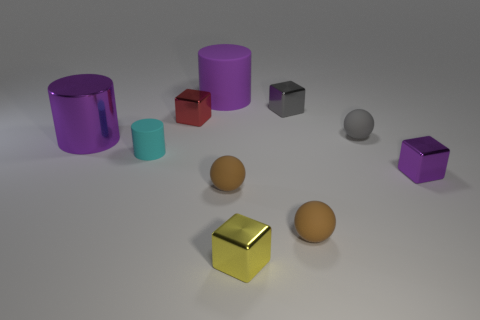Subtract all small gray balls. How many balls are left? 2 Subtract all balls. How many objects are left? 7 Subtract all brown cylinders. How many brown balls are left? 2 Subtract all gray spheres. How many spheres are left? 2 Subtract 1 cubes. How many cubes are left? 3 Subtract 1 purple cylinders. How many objects are left? 9 Subtract all purple cubes. Subtract all purple cylinders. How many cubes are left? 3 Subtract all balls. Subtract all tiny purple metal things. How many objects are left? 6 Add 9 tiny cyan rubber cylinders. How many tiny cyan rubber cylinders are left? 10 Add 6 tiny brown balls. How many tiny brown balls exist? 8 